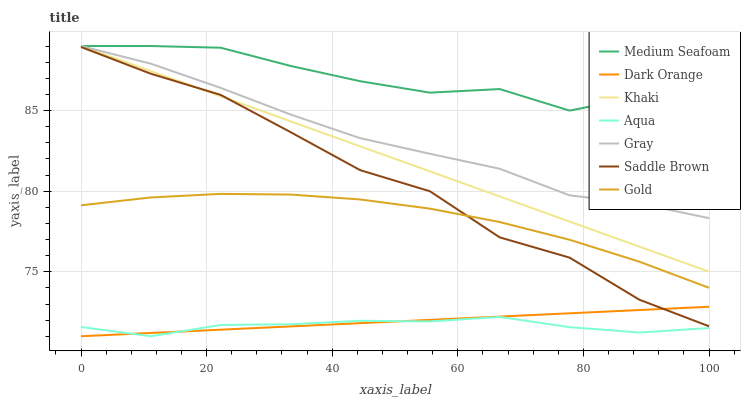Does Aqua have the minimum area under the curve?
Answer yes or no. Yes. Does Medium Seafoam have the maximum area under the curve?
Answer yes or no. Yes. Does Khaki have the minimum area under the curve?
Answer yes or no. No. Does Khaki have the maximum area under the curve?
Answer yes or no. No. Is Dark Orange the smoothest?
Answer yes or no. Yes. Is Medium Seafoam the roughest?
Answer yes or no. Yes. Is Khaki the smoothest?
Answer yes or no. No. Is Khaki the roughest?
Answer yes or no. No. Does Dark Orange have the lowest value?
Answer yes or no. Yes. Does Khaki have the lowest value?
Answer yes or no. No. Does Medium Seafoam have the highest value?
Answer yes or no. Yes. Does Gold have the highest value?
Answer yes or no. No. Is Aqua less than Medium Seafoam?
Answer yes or no. Yes. Is Khaki greater than Dark Orange?
Answer yes or no. Yes. Does Medium Seafoam intersect Gray?
Answer yes or no. Yes. Is Medium Seafoam less than Gray?
Answer yes or no. No. Is Medium Seafoam greater than Gray?
Answer yes or no. No. Does Aqua intersect Medium Seafoam?
Answer yes or no. No. 